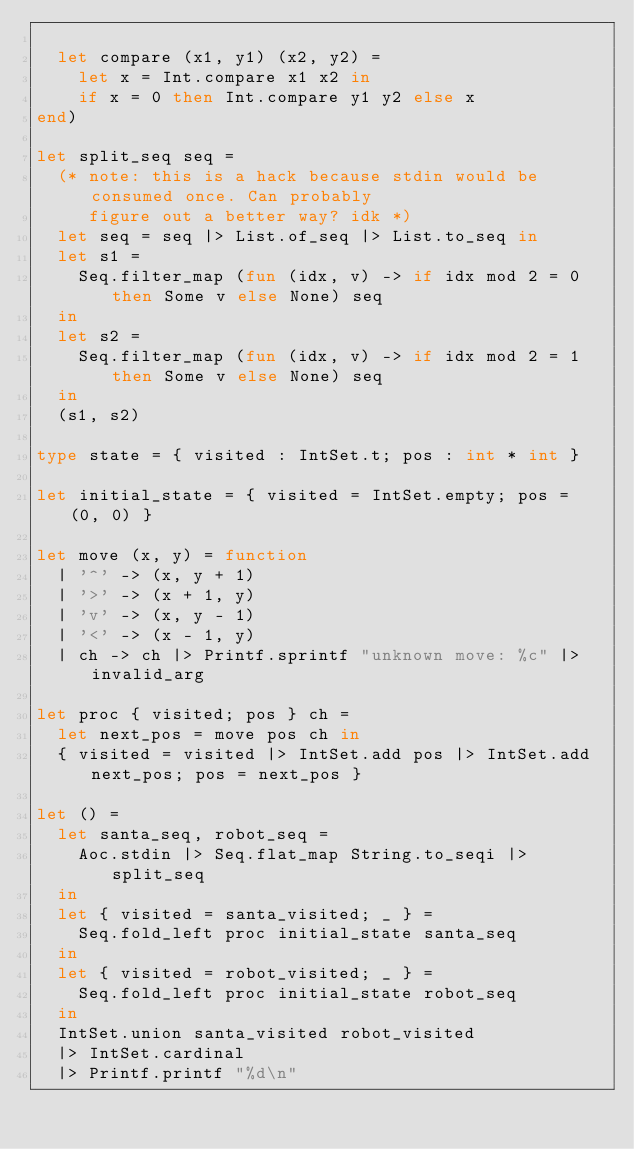Convert code to text. <code><loc_0><loc_0><loc_500><loc_500><_OCaml_>
  let compare (x1, y1) (x2, y2) =
    let x = Int.compare x1 x2 in
    if x = 0 then Int.compare y1 y2 else x
end)

let split_seq seq =
  (* note: this is a hack because stdin would be consumed once. Can probably
     figure out a better way? idk *)
  let seq = seq |> List.of_seq |> List.to_seq in
  let s1 =
    Seq.filter_map (fun (idx, v) -> if idx mod 2 = 0 then Some v else None) seq
  in
  let s2 =
    Seq.filter_map (fun (idx, v) -> if idx mod 2 = 1 then Some v else None) seq
  in
  (s1, s2)

type state = { visited : IntSet.t; pos : int * int }

let initial_state = { visited = IntSet.empty; pos = (0, 0) }

let move (x, y) = function
  | '^' -> (x, y + 1)
  | '>' -> (x + 1, y)
  | 'v' -> (x, y - 1)
  | '<' -> (x - 1, y)
  | ch -> ch |> Printf.sprintf "unknown move: %c" |> invalid_arg

let proc { visited; pos } ch =
  let next_pos = move pos ch in
  { visited = visited |> IntSet.add pos |> IntSet.add next_pos; pos = next_pos }

let () =
  let santa_seq, robot_seq =
    Aoc.stdin |> Seq.flat_map String.to_seqi |> split_seq
  in
  let { visited = santa_visited; _ } =
    Seq.fold_left proc initial_state santa_seq
  in
  let { visited = robot_visited; _ } =
    Seq.fold_left proc initial_state robot_seq
  in
  IntSet.union santa_visited robot_visited
  |> IntSet.cardinal
  |> Printf.printf "%d\n"
</code> 